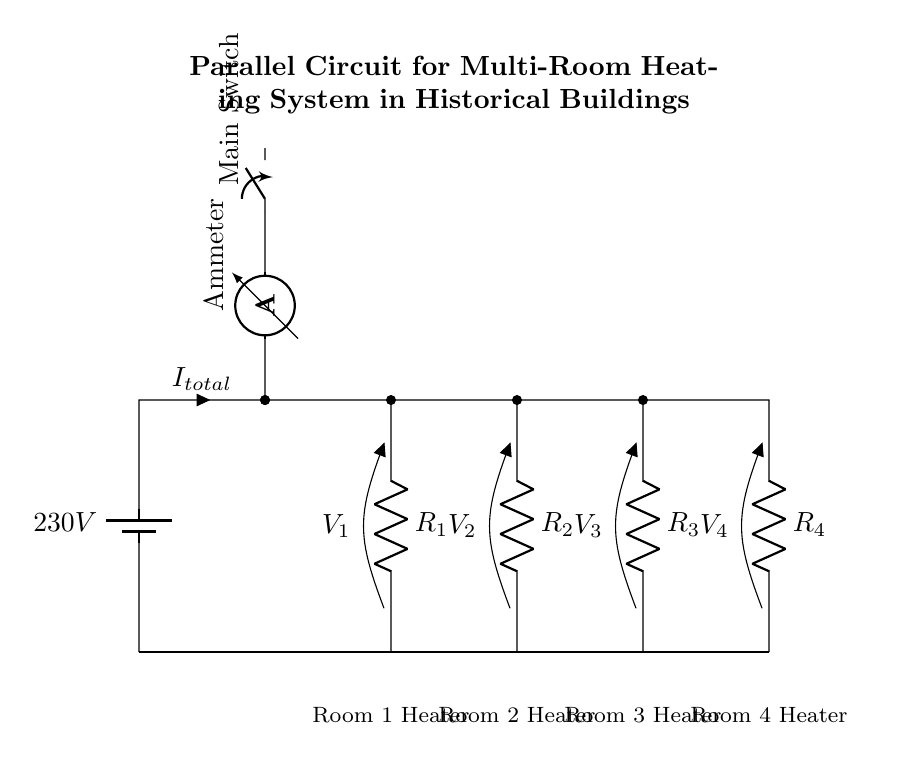What is the total voltage in this circuit? The total voltage is provided by the battery at the top, which is specified as 230 volts. This is the voltage available for the entire series of components connected in parallel.
Answer: 230 volts What type of circuit is this? This is a parallel circuit. The heaters (R1, R2, R3, R4) are connected in parallel to the power source, meaning each has its own path for current to flow, which indicates a characteristic of parallel circuits.
Answer: Parallel circuit How many heaters are included in this circuit? The circuit diagram shows four resistors labeled as R1, R2, R3, and R4, each representing a heater in different rooms, indicating there are four heaters in total.
Answer: Four heaters What is the purpose of the ammeter in this circuit? The ammeter is used to measure the total current flowing through the circuit. It is placed in series with the battery, as indicated by its connection in-line with the circuit.
Answer: Measure total current What does the switch in the circuit represent? The switch represents a manual control to turn the entire heating system on or off. If the switch is open, it will break the circuit, preventing any current from flowing to the heaters.
Answer: Main control for heating Which heater corresponds to R3? R3 corresponds to the heater in Room 3 as indicated by the labeling beneath the circuit diagram where each room is matched with its respective resistor.
Answer: Room 3 Heater 